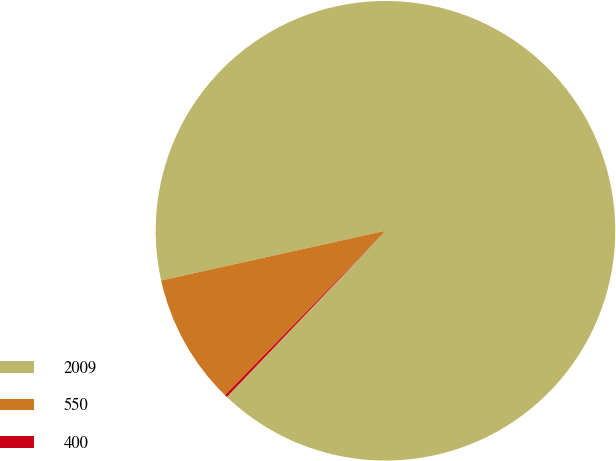Convert chart. <chart><loc_0><loc_0><loc_500><loc_500><pie_chart><fcel>2009<fcel>550<fcel>400<nl><fcel>90.6%<fcel>9.22%<fcel>0.18%<nl></chart> 